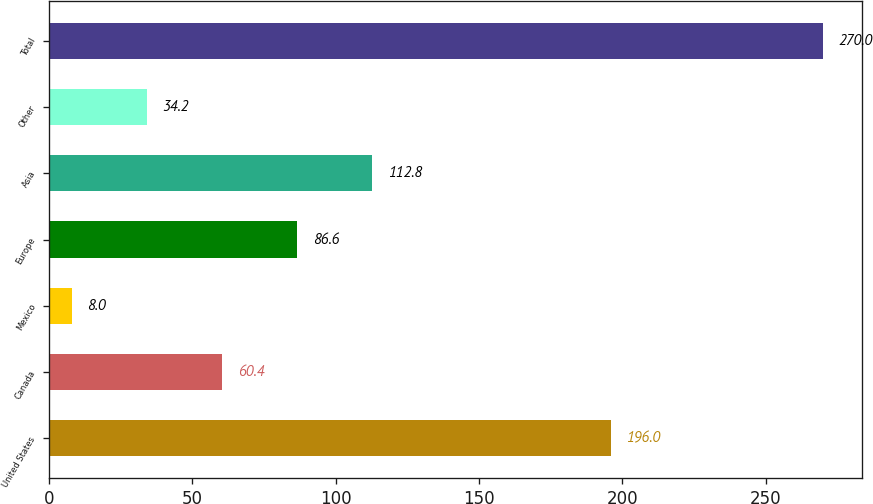Convert chart. <chart><loc_0><loc_0><loc_500><loc_500><bar_chart><fcel>United States<fcel>Canada<fcel>Mexico<fcel>Europe<fcel>Asia<fcel>Other<fcel>Total<nl><fcel>196<fcel>60.4<fcel>8<fcel>86.6<fcel>112.8<fcel>34.2<fcel>270<nl></chart> 